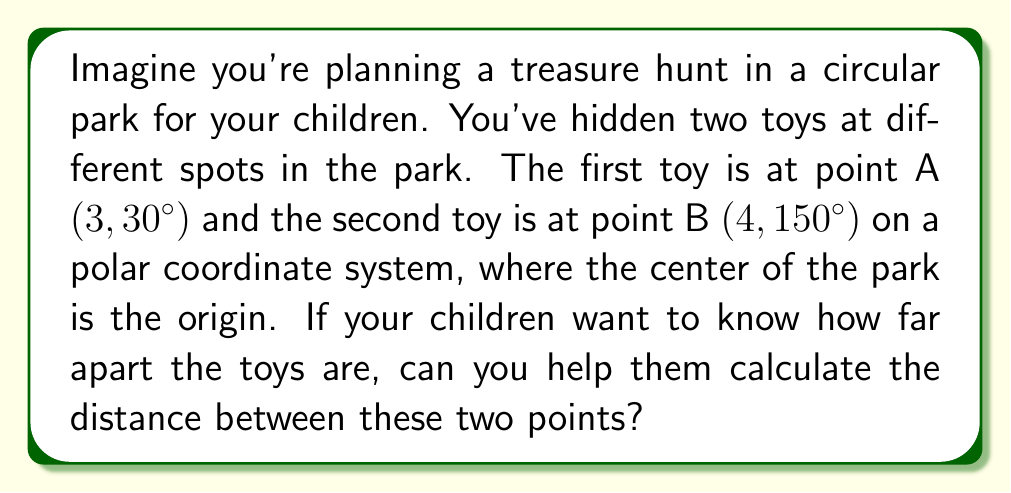Solve this math problem. To find the distance between two points on a polar graph, we can use the polar form of the distance formula:

$$d = \sqrt{r_1^2 + r_2^2 - 2r_1r_2\cos(\theta_2 - \theta_1)}$$

Where:
- $d$ is the distance between the two points
- $r_1$ and $r_2$ are the radial distances of the two points
- $\theta_1$ and $\theta_2$ are the polar angles of the two points

Let's plug in our values:
- Point A: $r_1 = 3$, $\theta_1 = 30°$
- Point B: $r_2 = 4$, $\theta_2 = 150°$

Step 1: Calculate $\theta_2 - \theta_1$
$150° - 30° = 120°$

Step 2: Apply the formula
$$\begin{align*}
d &= \sqrt{3^2 + 4^2 - 2(3)(4)\cos(120°)} \\
&= \sqrt{9 + 16 - 24\cos(120°)}
\end{align*}$$

Step 3: Evaluate $\cos(120°)$
$\cos(120°) = -0.5$

Step 4: Simplify and calculate
$$\begin{align*}
d &= \sqrt{9 + 16 - 24(-0.5)} \\
&= \sqrt{9 + 16 + 12} \\
&= \sqrt{37} \\
&\approx 6.08
\end{align*}$$

Therefore, the distance between the two toys is approximately 6.08 units (which could represent meters or any other unit of length used in the park).
Answer: The distance between the two points is $\sqrt{37}$ units, or approximately 6.08 units. 